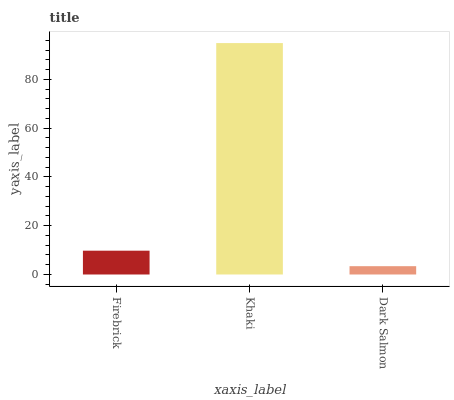Is Dark Salmon the minimum?
Answer yes or no. Yes. Is Khaki the maximum?
Answer yes or no. Yes. Is Khaki the minimum?
Answer yes or no. No. Is Dark Salmon the maximum?
Answer yes or no. No. Is Khaki greater than Dark Salmon?
Answer yes or no. Yes. Is Dark Salmon less than Khaki?
Answer yes or no. Yes. Is Dark Salmon greater than Khaki?
Answer yes or no. No. Is Khaki less than Dark Salmon?
Answer yes or no. No. Is Firebrick the high median?
Answer yes or no. Yes. Is Firebrick the low median?
Answer yes or no. Yes. Is Khaki the high median?
Answer yes or no. No. Is Dark Salmon the low median?
Answer yes or no. No. 